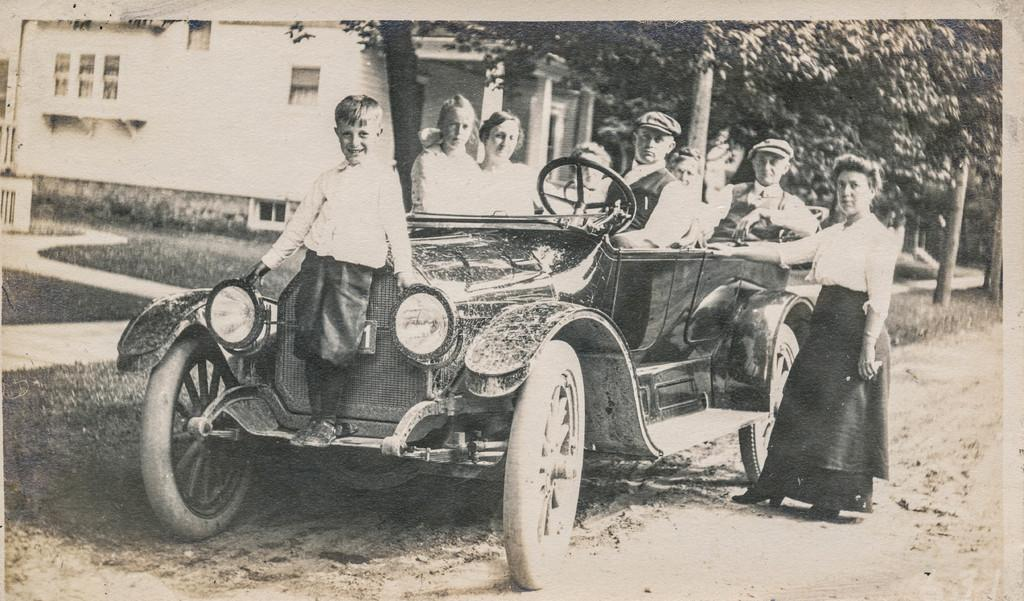What is the main subject of the image? There is a vehicle in the image. Who or what is inside the vehicle? There are people sitting in the vehicle. Can you describe the woman standing near the vehicle? There is a woman standing near the vehicle. What can be seen in the background of the image? There are trees and a building in the background of the image. What type of cord is being used to tie the bike to the vehicle in the image? There is no bike or cord present in the image. What kind of shoes is the woman wearing in the image? The image does not show the woman's shoes, so it cannot be determined from the image. 